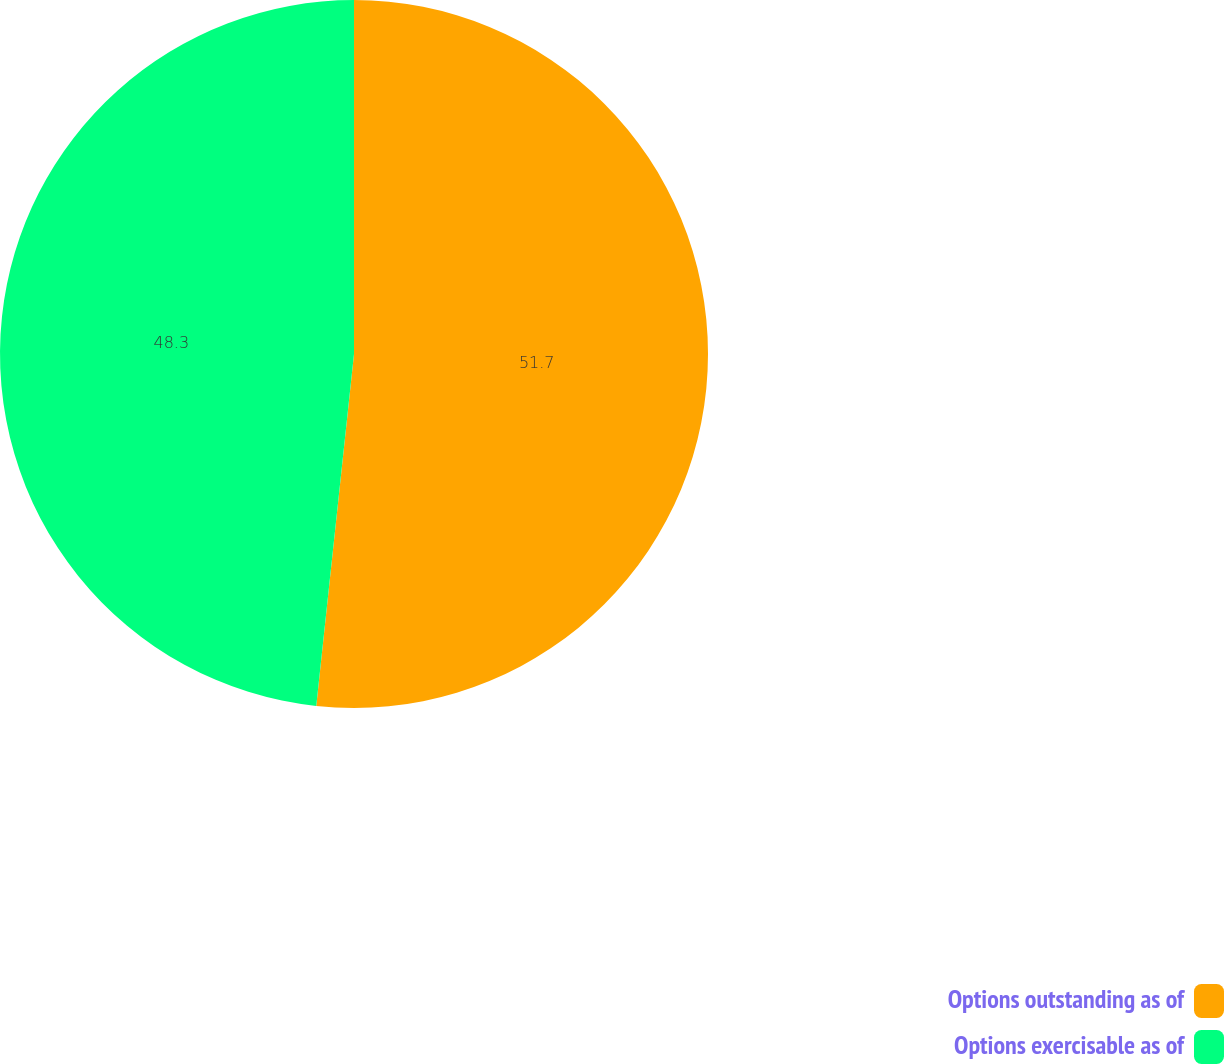Convert chart to OTSL. <chart><loc_0><loc_0><loc_500><loc_500><pie_chart><fcel>Options outstanding as of<fcel>Options exercisable as of<nl><fcel>51.7%<fcel>48.3%<nl></chart> 